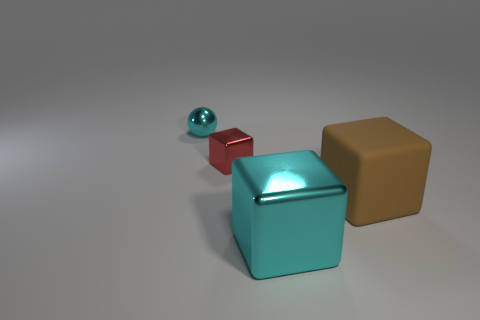Add 3 small cyan spheres. How many objects exist? 7 Subtract all balls. How many objects are left? 3 Subtract all brown matte things. Subtract all small balls. How many objects are left? 2 Add 4 tiny red metal objects. How many tiny red metal objects are left? 5 Add 3 large blocks. How many large blocks exist? 5 Subtract 0 brown cylinders. How many objects are left? 4 